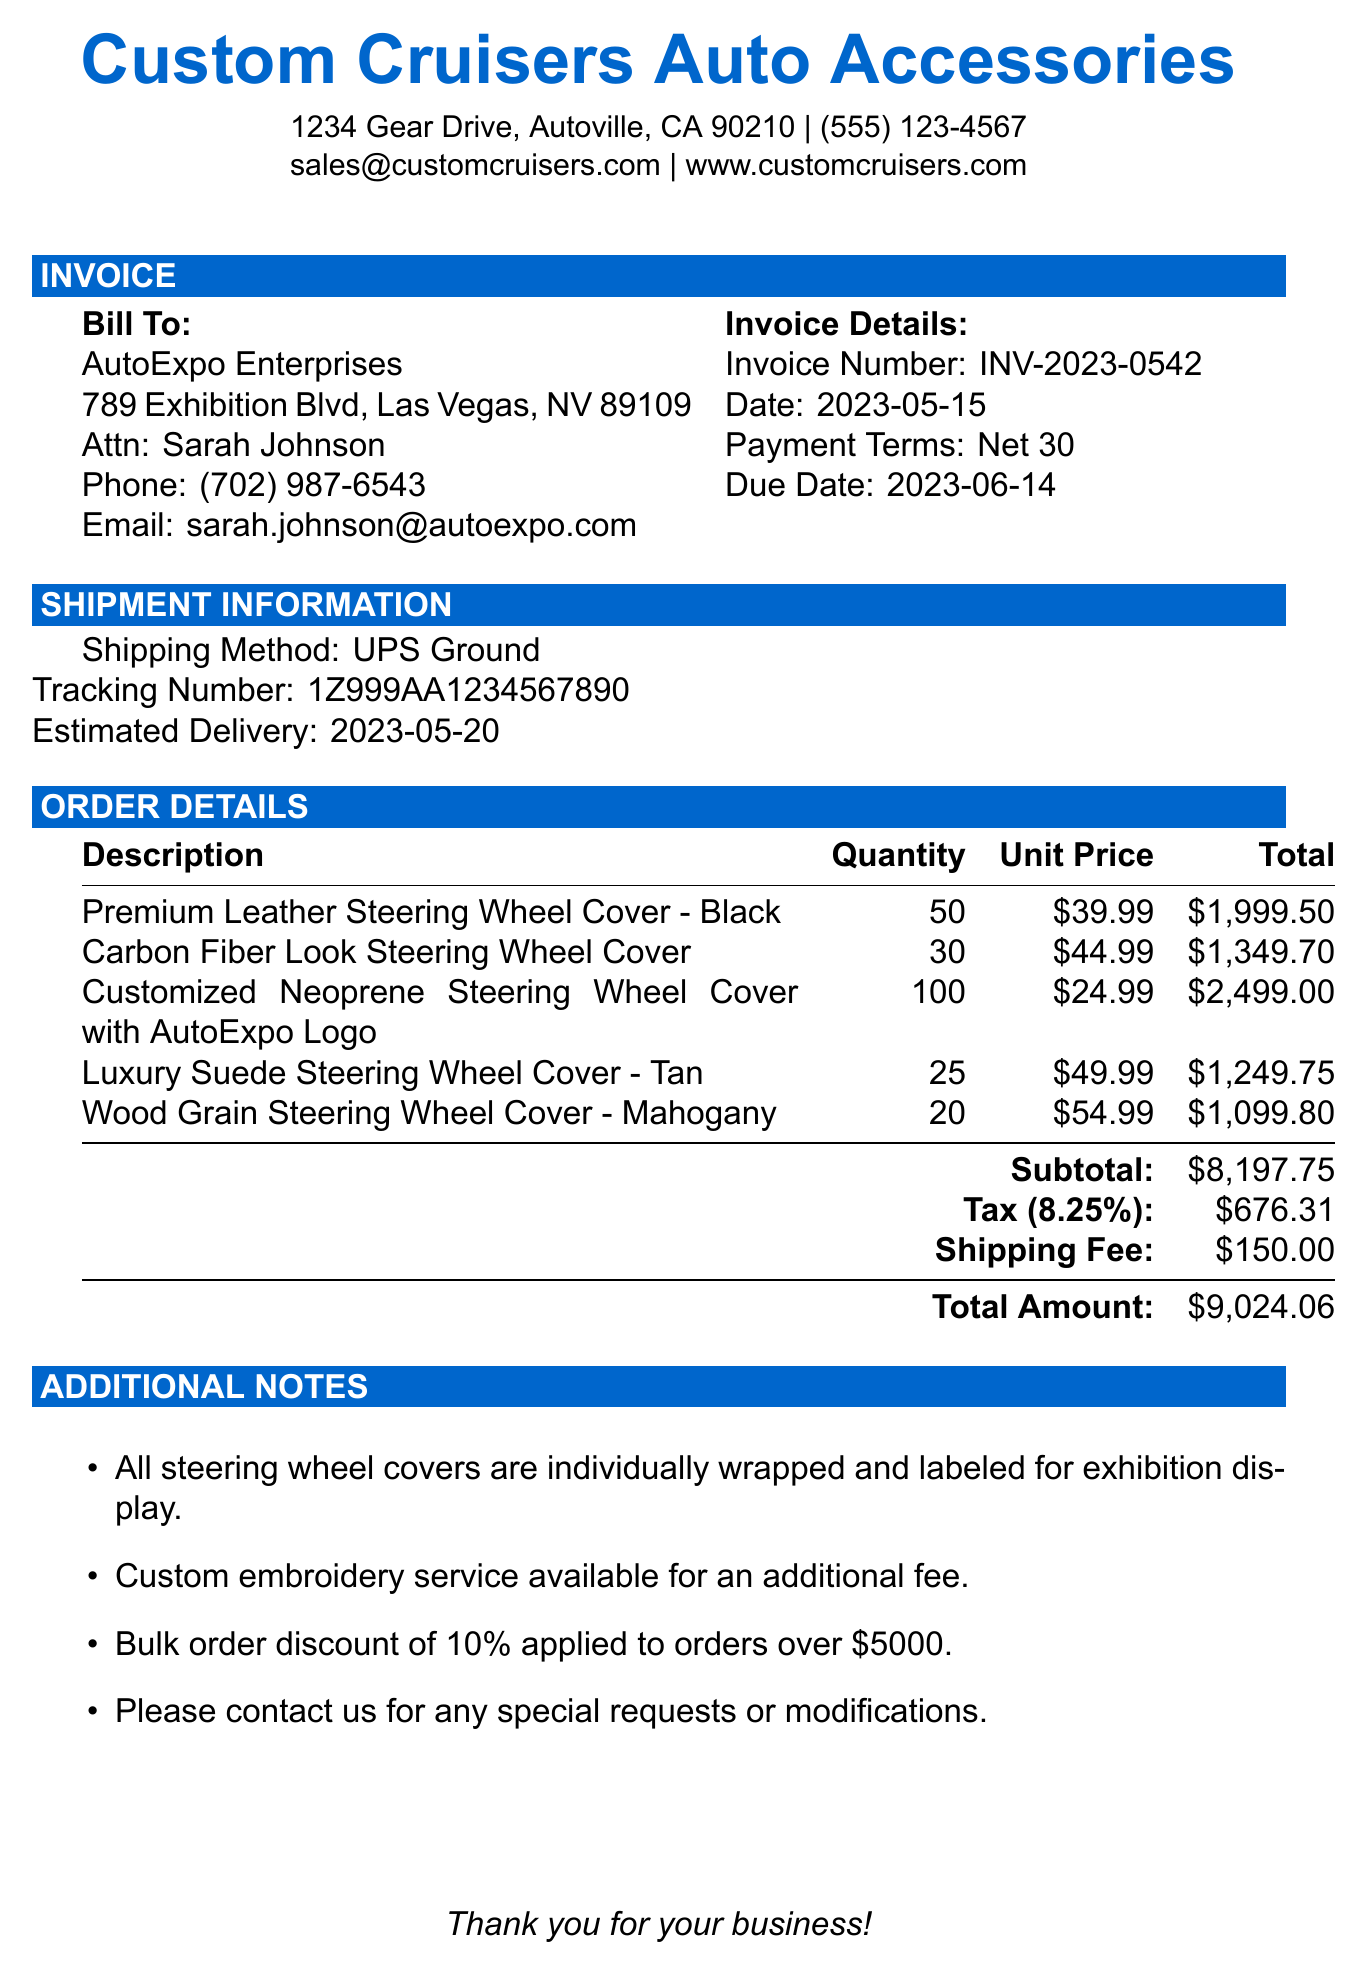what is the invoice number? The invoice number is listed under the invoice details section in the document.
Answer: INV-2023-0542 who is the contact person for the customer? The contact person's name is specified in the customer information section of the document.
Answer: Sarah Johnson what is the total amount due? The total amount is found at the end of the order details section, which summarizes the costs.
Answer: $9,024.06 how many Premium Leather Steering Wheel Covers were ordered? The quantity for the Premium Leather Steering Wheel Cover is mentioned in the order details section.
Answer: 50 what is the shipping method used for this order? The shipping method is provided in the shipment information section of the document.
Answer: UPS Ground what is the tax rate applied to the invoice? The tax rate can be found in the order details section, adjacent to the tax amount.
Answer: 8.25% what is the due date for this invoice? The due date is specified in the invoice details section.
Answer: 2023-06-14 how much is the shipping fee? The shipping fee is indicated in the order details section of the document.
Answer: $150.00 what is noted about the packaging of the items? Additional notes provide information about how the items are wrapped for order fulfillment.
Answer: Individually wrapped and labeled for exhibition display 